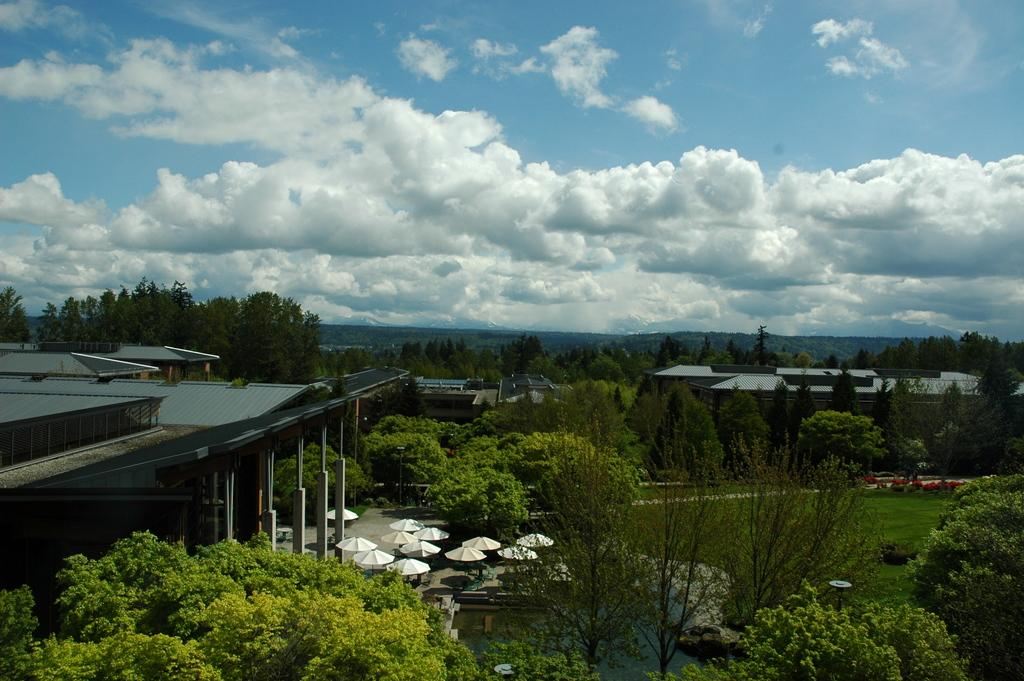What can be seen on the left side of the image? There are buildings towards the left side of the image. What is placed in front of the buildings? There are umbrellas before the buildings. What natural elements are visible at the top of the image? Trees and water are visible at the top of the image. What is visible in the background of the image? There are buildings and trees in the background of the image, as well as the sky. What type of rest can be seen being taken by the people in the image? There are no people visible in the image, so it is not possible to determine if anyone is taking rest. What type of pleasure can be seen being derived from the image? There is no indication of pleasure being derived from the image, as it primarily features buildings, umbrellas, trees, water, and the sky. 